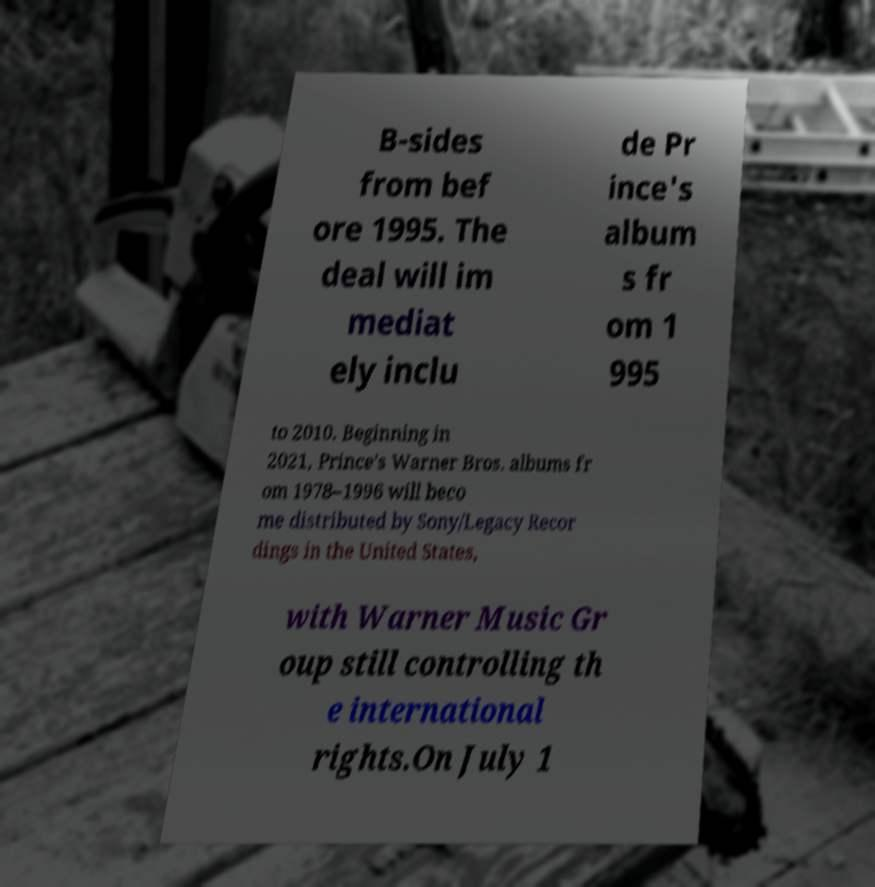For documentation purposes, I need the text within this image transcribed. Could you provide that? B-sides from bef ore 1995. The deal will im mediat ely inclu de Pr ince's album s fr om 1 995 to 2010. Beginning in 2021, Prince's Warner Bros. albums fr om 1978–1996 will beco me distributed by Sony/Legacy Recor dings in the United States, with Warner Music Gr oup still controlling th e international rights.On July 1 